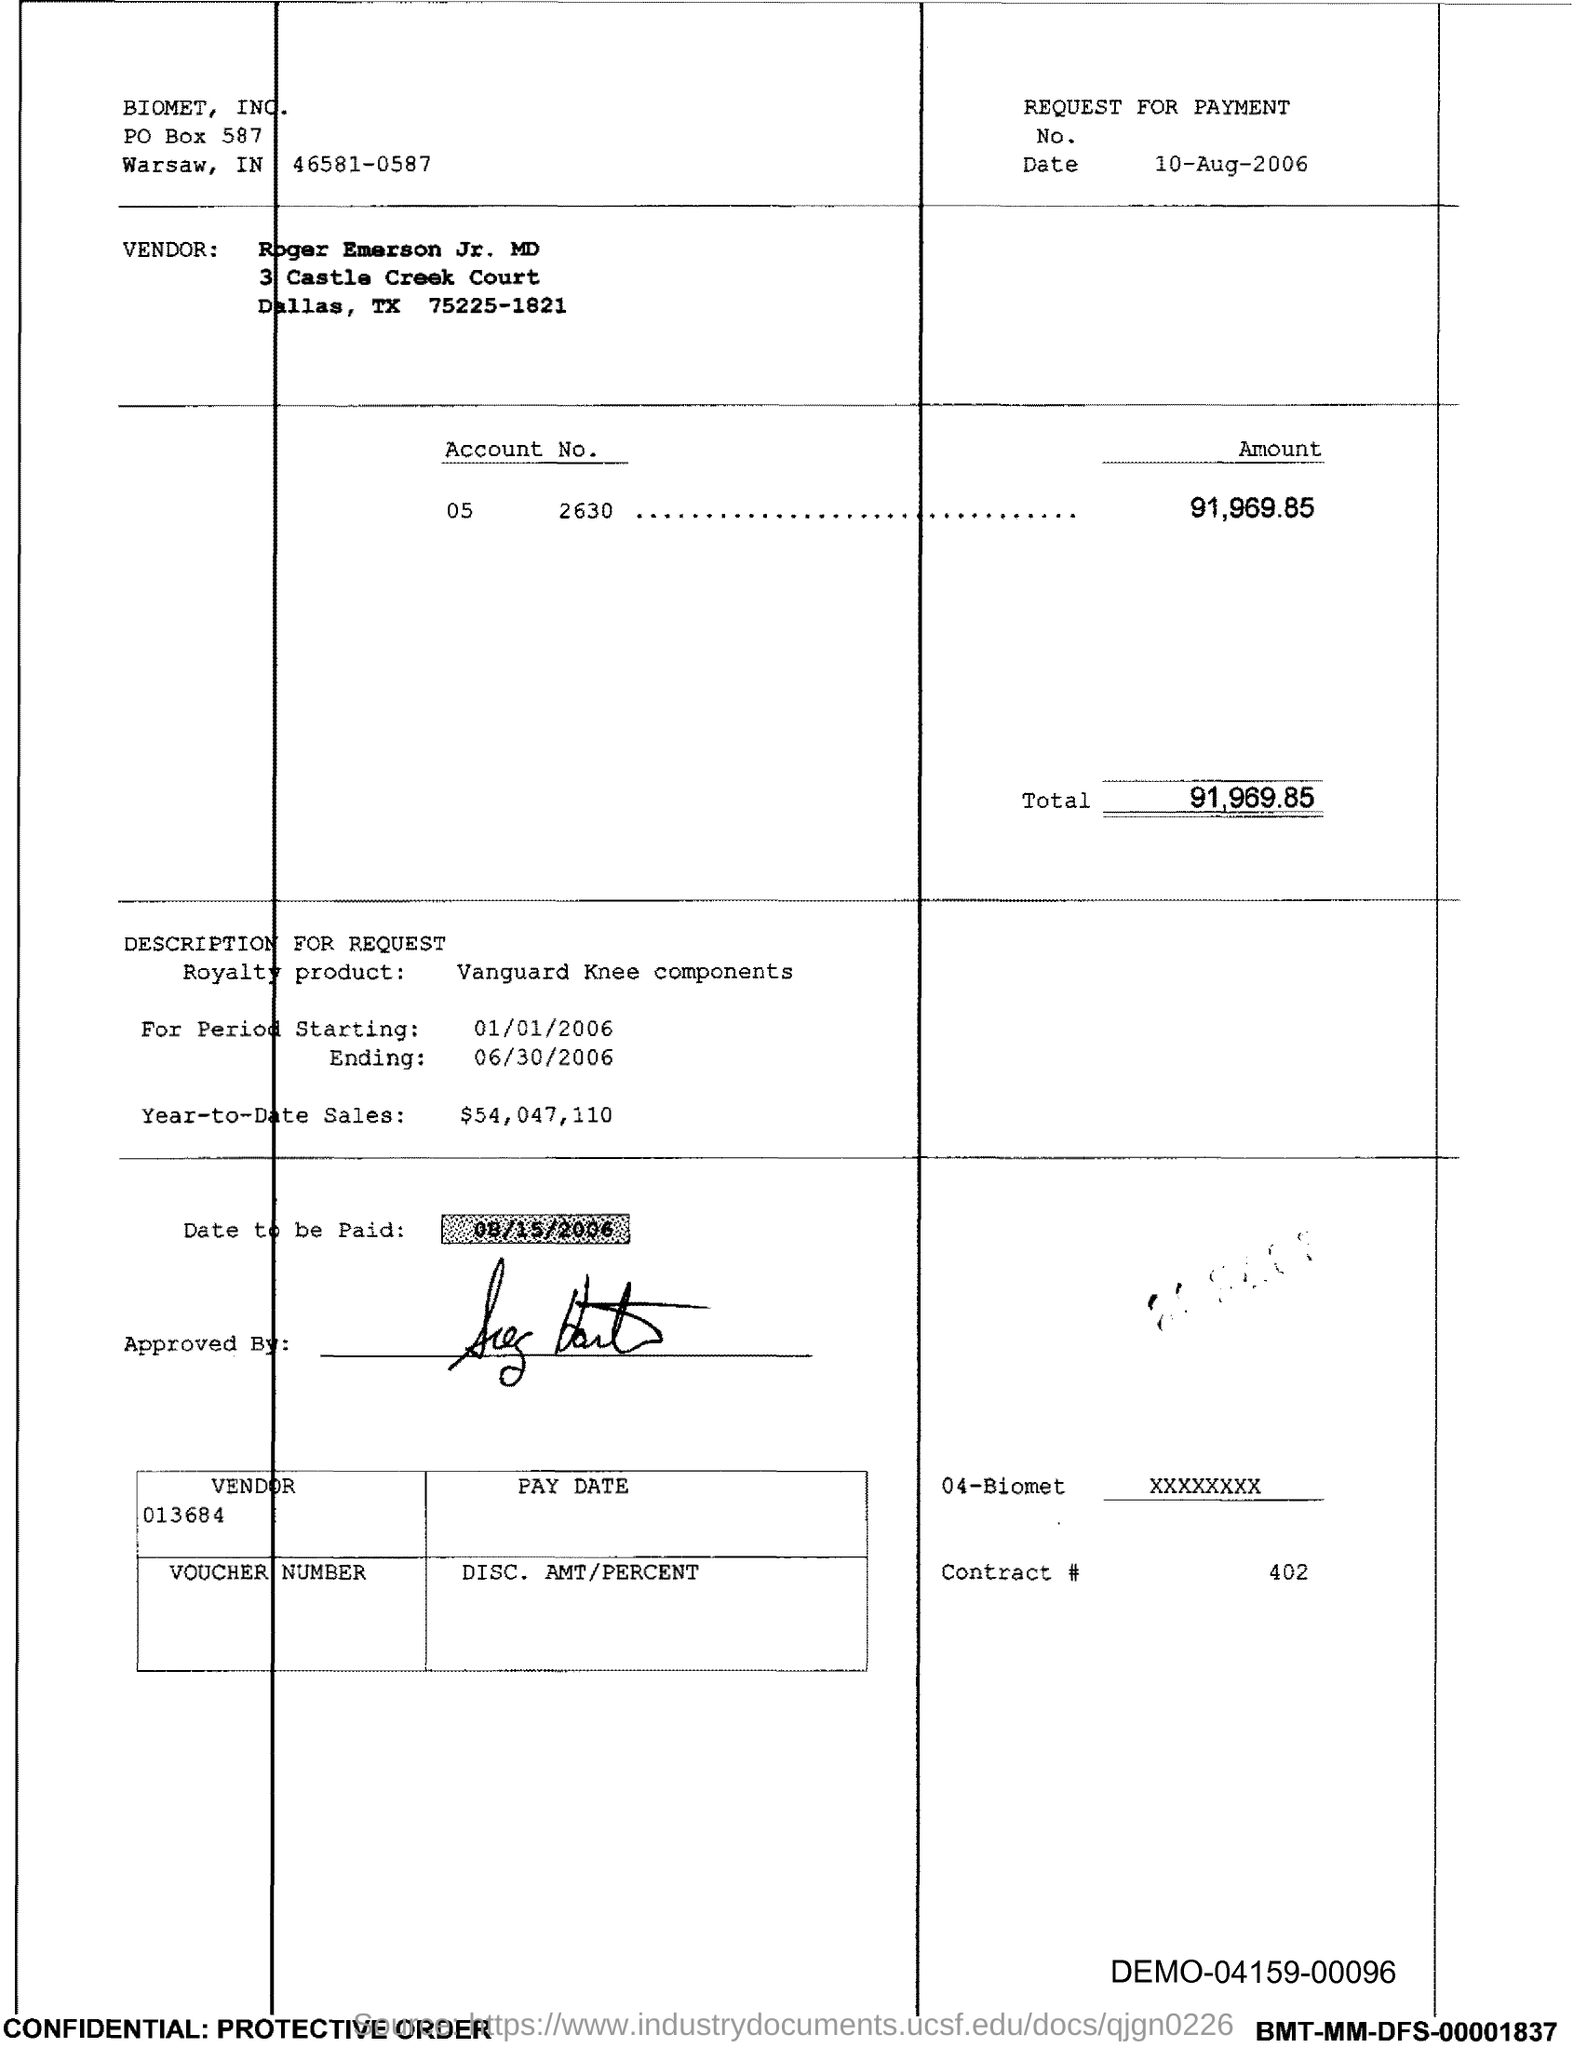Identify some key points in this picture. This document pertains to a request for payment. The date to be paid is August 15, 2006. The Royalty product mentioned is Vanguard Knee Components. The account number is 05 and the amount in the account is 91,969.85. The period is starting on January 1, 2006. 